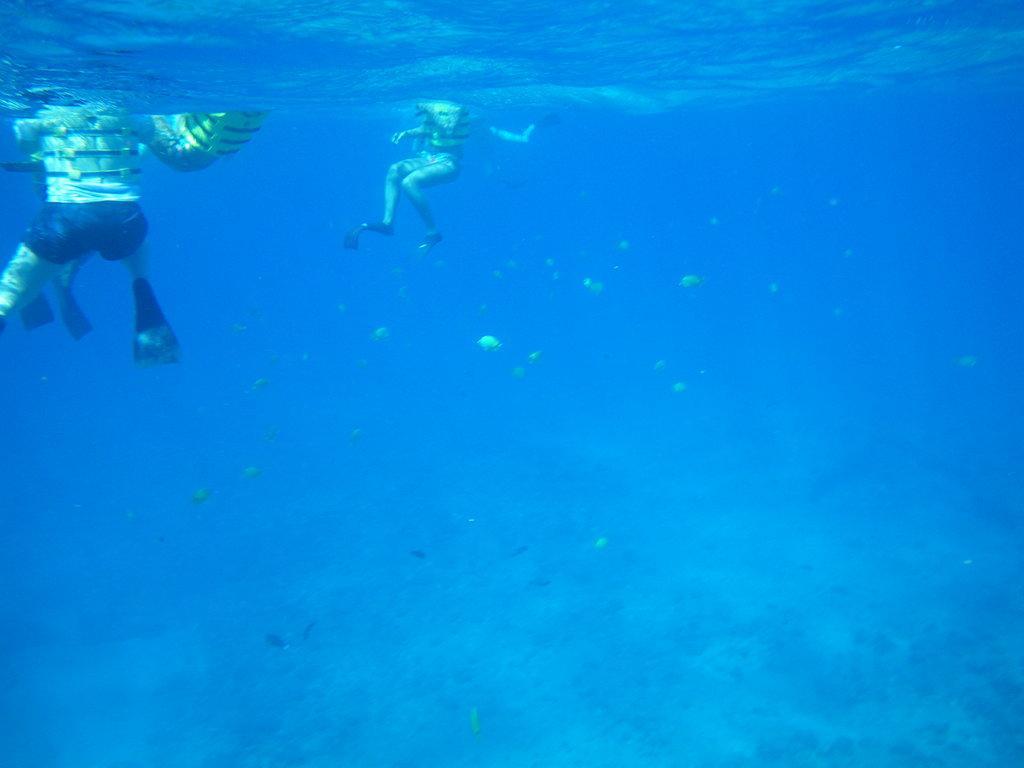In one or two sentences, can you explain what this image depicts? It is an underwater image, there are few people swimming in the sea and below them there are small fishes. 